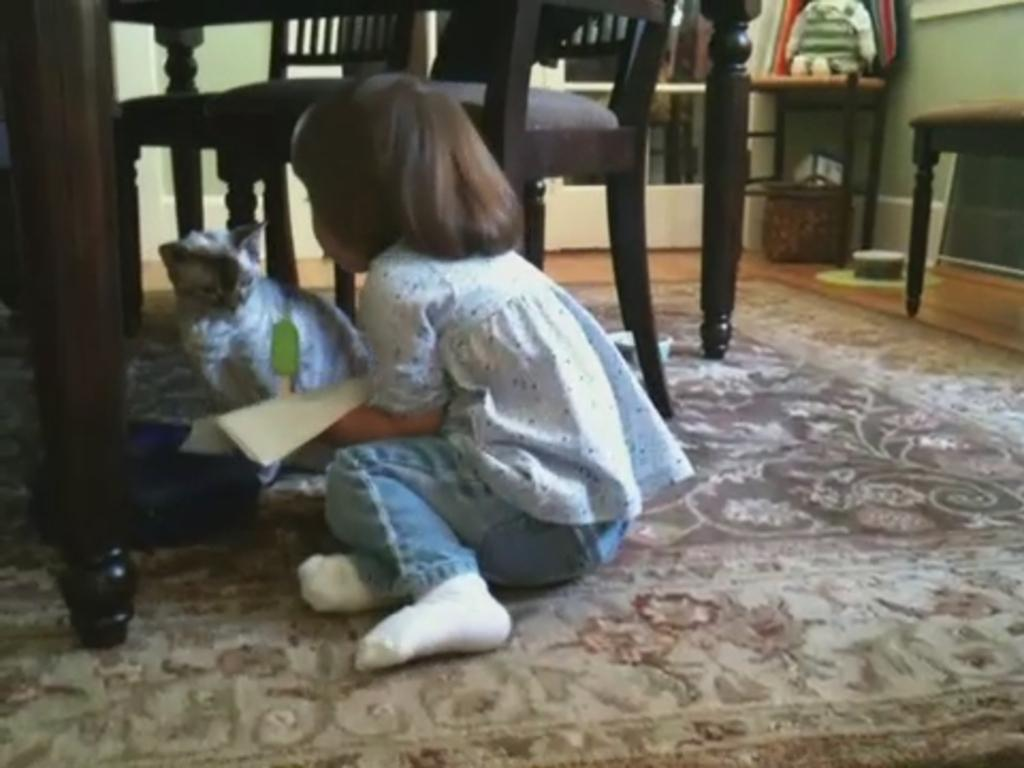What is present in the image along with the child? There is a cat in the image along with the child. Where are the child and the cat located in the image? Both the child and the cat are on the floor in the image. What type of furniture can be seen in the image? There are chairs in the image. What is visible in the background of the image? There is a wall in the background of the image. How does the jellyfish interact with the child in the image? There is no jellyfish present in the image; it only features a child and a cat. What is the reason for the car being parked in the image? There is no car present in the image, so it is not possible to determine the reason for its presence. 